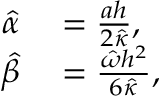Convert formula to latex. <formula><loc_0><loc_0><loc_500><loc_500>\begin{array} { r l } { \hat { \alpha } } & = \frac { a h } { 2 \hat { \kappa } } , } \\ { \hat { \beta } } & = \frac { \hat { \omega } h ^ { 2 } } { 6 \hat { \kappa } } , } \end{array}</formula> 